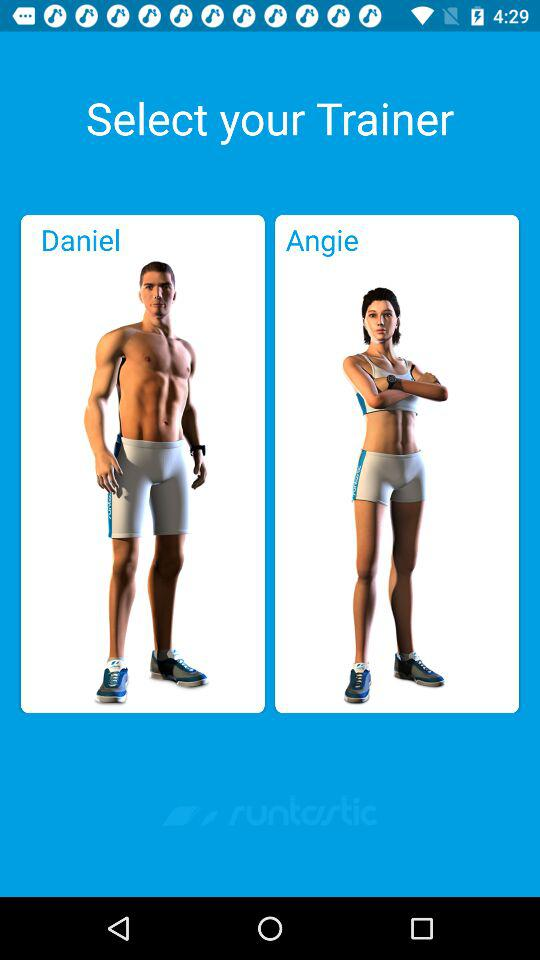Which trainers can I select? The trainers that I can select are "Daniel" and "Angie". 